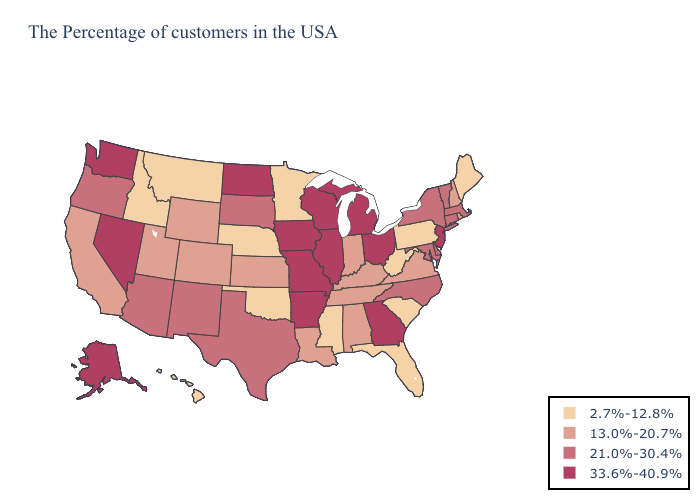What is the value of Texas?
Answer briefly. 21.0%-30.4%. Name the states that have a value in the range 2.7%-12.8%?
Answer briefly. Maine, Pennsylvania, South Carolina, West Virginia, Florida, Mississippi, Minnesota, Nebraska, Oklahoma, Montana, Idaho, Hawaii. Does Nebraska have the highest value in the MidWest?
Give a very brief answer. No. Does Arizona have the lowest value in the West?
Short answer required. No. What is the highest value in states that border Virginia?
Give a very brief answer. 21.0%-30.4%. What is the lowest value in states that border North Carolina?
Quick response, please. 2.7%-12.8%. Name the states that have a value in the range 33.6%-40.9%?
Quick response, please. New Jersey, Ohio, Georgia, Michigan, Wisconsin, Illinois, Missouri, Arkansas, Iowa, North Dakota, Nevada, Washington, Alaska. Name the states that have a value in the range 21.0%-30.4%?
Concise answer only. Massachusetts, Vermont, Connecticut, New York, Delaware, Maryland, North Carolina, Texas, South Dakota, New Mexico, Arizona, Oregon. Does Washington have a higher value than Michigan?
Quick response, please. No. Among the states that border Massachusetts , does Rhode Island have the highest value?
Keep it brief. No. Does Arkansas have the same value as Utah?
Be succinct. No. Among the states that border Alabama , which have the highest value?
Quick response, please. Georgia. Which states have the lowest value in the USA?
Be succinct. Maine, Pennsylvania, South Carolina, West Virginia, Florida, Mississippi, Minnesota, Nebraska, Oklahoma, Montana, Idaho, Hawaii. What is the value of Virginia?
Give a very brief answer. 13.0%-20.7%. Among the states that border Pennsylvania , which have the lowest value?
Be succinct. West Virginia. 